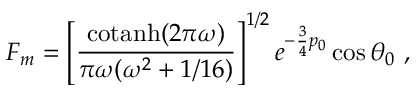Convert formula to latex. <formula><loc_0><loc_0><loc_500><loc_500>F _ { m } = \left [ { \frac { c o t a n h ( 2 \pi \omega ) } { \pi \omega ( \omega ^ { 2 } + 1 / 1 6 ) } } \right ] ^ { 1 / 2 } e ^ { - { \frac { 3 } { 4 } } p _ { 0 } } \cos \theta _ { 0 } \ ,</formula> 